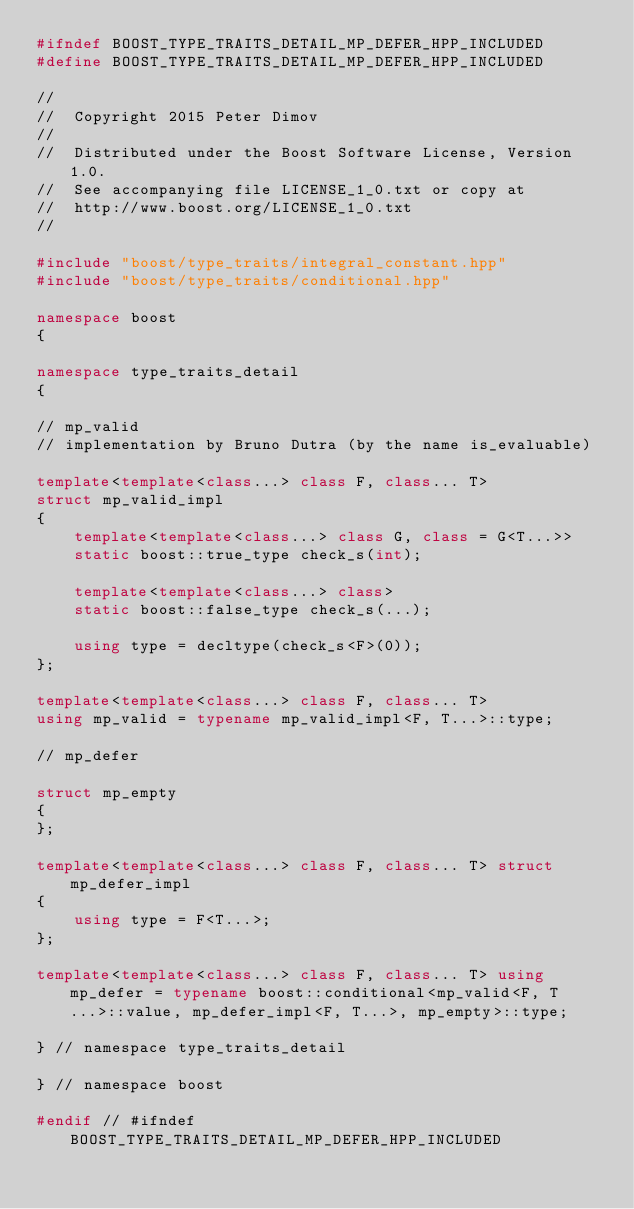<code> <loc_0><loc_0><loc_500><loc_500><_C++_>#ifndef BOOST_TYPE_TRAITS_DETAIL_MP_DEFER_HPP_INCLUDED
#define BOOST_TYPE_TRAITS_DETAIL_MP_DEFER_HPP_INCLUDED

//
//  Copyright 2015 Peter Dimov
//
//  Distributed under the Boost Software License, Version 1.0.
//  See accompanying file LICENSE_1_0.txt or copy at
//  http://www.boost.org/LICENSE_1_0.txt
//

#include "boost/type_traits/integral_constant.hpp"
#include "boost/type_traits/conditional.hpp"

namespace boost
{

namespace type_traits_detail
{

// mp_valid
// implementation by Bruno Dutra (by the name is_evaluable)

template<template<class...> class F, class... T>
struct mp_valid_impl
{
    template<template<class...> class G, class = G<T...>>
    static boost::true_type check_s(int);

    template<template<class...> class>
    static boost::false_type check_s(...);

    using type = decltype(check_s<F>(0));
};

template<template<class...> class F, class... T>
using mp_valid = typename mp_valid_impl<F, T...>::type;

// mp_defer

struct mp_empty
{
};

template<template<class...> class F, class... T> struct mp_defer_impl
{
    using type = F<T...>;
};

template<template<class...> class F, class... T> using mp_defer = typename boost::conditional<mp_valid<F, T...>::value, mp_defer_impl<F, T...>, mp_empty>::type;

} // namespace type_traits_detail

} // namespace boost

#endif // #ifndef BOOST_TYPE_TRAITS_DETAIL_MP_DEFER_HPP_INCLUDED
</code> 